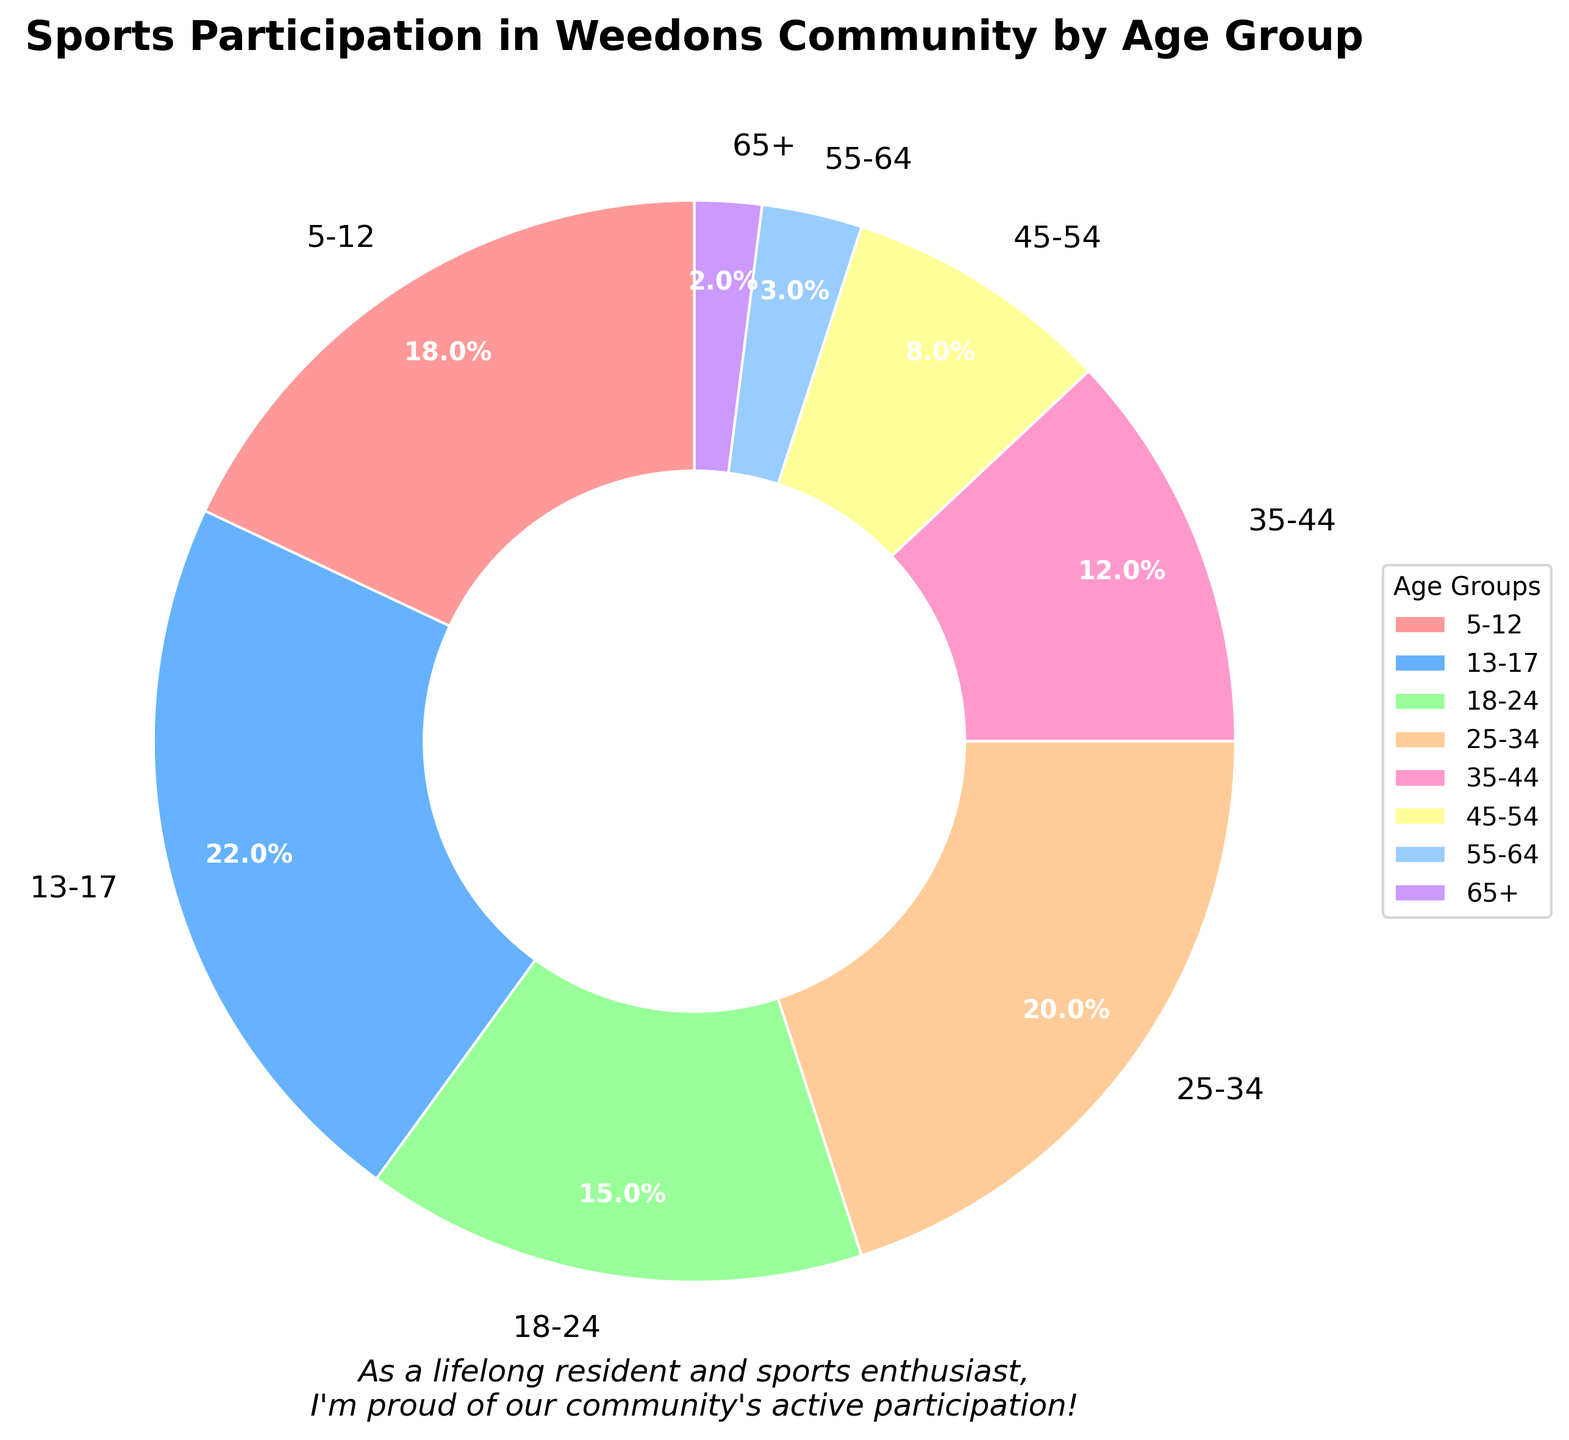What age group has the highest participation percentage? Looking at the pie chart, the largest section belongs to the age group 13-17.
Answer: 13-17 Which two age groups combined account for the same percentage of participation as the age group 25-34? The 25-34 age group has a 20% participation. Adding the percentages of the 35-44 (12%) and 45-54 (8%) age groups, we get 12% + 8% = 20%, which matches the participation percentage of the 25-34 age group.
Answer: 35-44 and 45-54 Which age group has the lowest participation percentage? From the pie chart, the smallest section is for the 65+ age group.
Answer: 65+ How much more is the participation percentage for the 13-17 age group compared to the 45-54 age group? The 13-17 age group has a 22% participation, and the 45-54 age group has an 8% participation. Subtracting the two, we get 22% - 8% = 14%.
Answer: 14% Is the participation percentage of the 18-24 age group greater than that of the 35-44 age group? The 18-24 age group has a 15% participation, whereas the 35-44 age group has a 12% participation. 15% is greater than 12%.
Answer: Yes Which color corresponds to the 5-12 age group in the chart? By looking at the pie chart, the section labeled 5-12 is colored in a shade of light pink/red.
Answer: Light pink/red What is the combined participation percentage for the age groups 45-54, 55-64, and 65+? Adding the percentages of the 45-54 (8%), 55-64 (3%), and 65+ (2%) age groups, we get 8% + 3% + 2% = 13%.
Answer: 13% Calculate the average participation percentage for the age groups 13-17, 18-24, and 25-34. The percentages for these age groups are 22%, 15%, and 20%, respectively. Adding them gives us 22% + 15% + 20% = 57%. Dividing by 3, the average is 57% / 3 = 19%.
Answer: 19% Does the section for the 25-34 age group have a larger or smaller area compared to the 5-12 age group? The 25-34 age group has a 20% participation, while the 5-12 age group has an 18% participation. 20% is larger than 18%.
Answer: Larger What percentage of the community's sports participants are aged 25 or older? Adding the percentages for the age groups 25-34 (20%), 35-44 (12%), 45-54 (8%), 55-64 (3%), and 65+ (2%), we get 20% + 12% + 8% + 3% + 2% = 45%.
Answer: 45% 